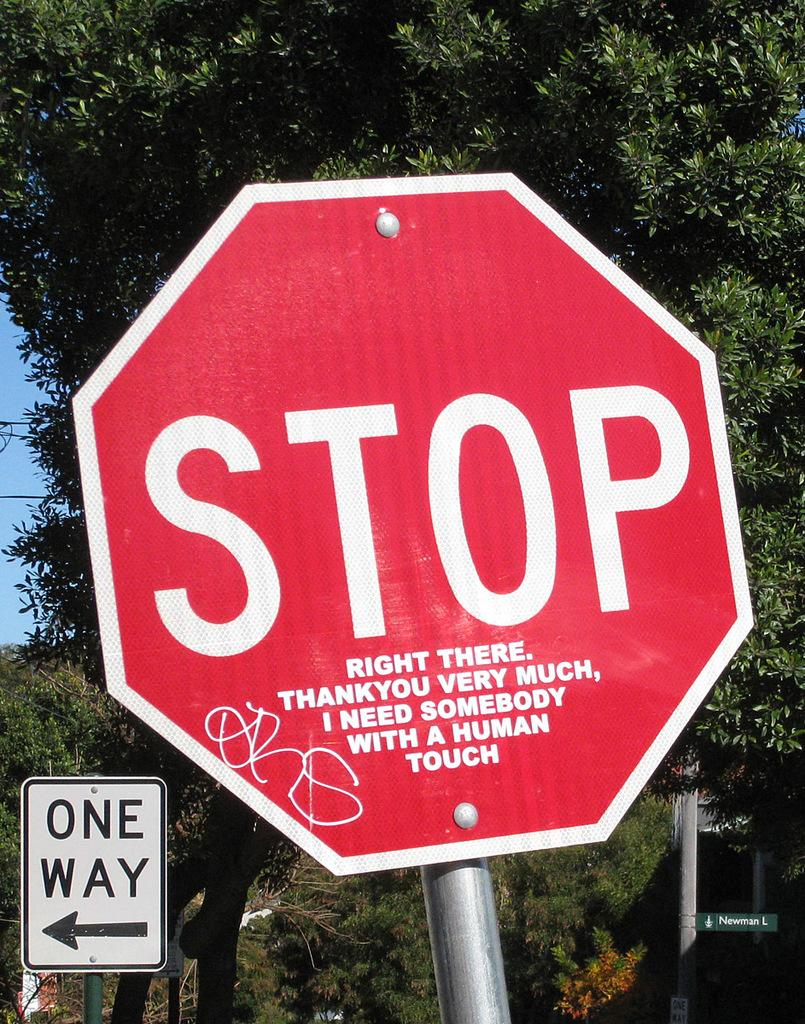Provide a one-sentence caption for the provided image. Someone added "right there..." to the stop sign to make it humorous. 